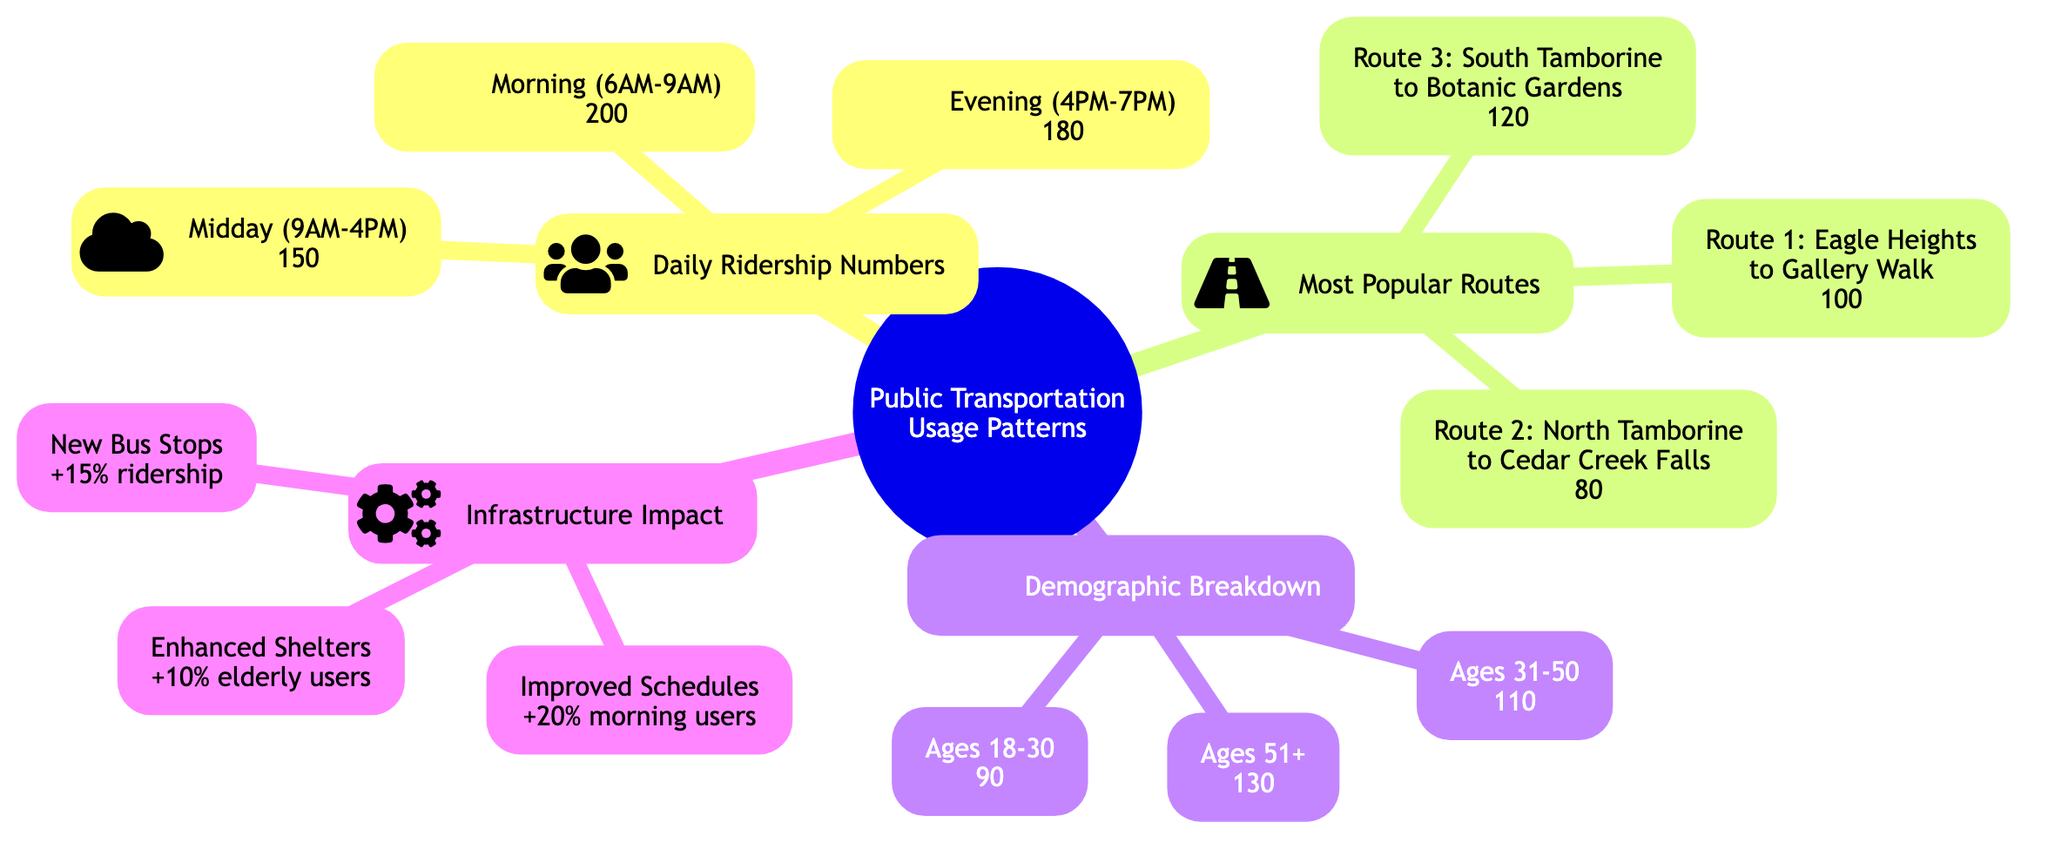What is the total ridership during morning hours? The daily ridership numbers indicate that the total ridership in the morning (6AM-9AM) is 200.
Answer: 200 What is the most popular route? Comparing the numbers in the "Most Popular Routes" section, Route 1, which goes from Eagle Heights to Gallery Walk, has the highest ridership at 100.
Answer: Route 1: Eagle Heights to Gallery Walk How many riders are aged 31-50? In the "Demographic Breakdown" section, it shows that the number of riders aged 31-50 is 110.
Answer: 110 What increase in ridership is expected from new bus stops? The "Infrastructure Impact" section states that new bus stops are anticipated to increase ridership by 15%.
Answer: +15% What is the total ridership during midday? The diagram shows a ridership count during midday (9AM-4PM) of 150, as indicated in the "Daily Ridership Numbers" section.
Answer: 150 Which age group has the highest ridership? From the "Demographic Breakdown" section, it can be observed that the age group 51+ has the highest ridership, accounting for 130 riders.
Answer: Ages 51+: 130 What impact do improved schedules have on morning users? The diagram notes that improved schedules are projected to increase morning users by 20%, as listed in the "Infrastructure Impact" section.
Answer: +20% What is the ridership for Route 3? The information in the "Most Popular Routes" section specifies that Route 3, from South Tamborine to Botanic Gardens, has a ridership of 120.
Answer: 120 How does the ridership of the 18-30 age group compare to the 51+ age group? By comparing the "Demographic Breakdown" numbers, it can be seen that the 18-30 age group has 90 riders, which is 40 less than the 51+ age group, which has 130.
Answer: 40 less 